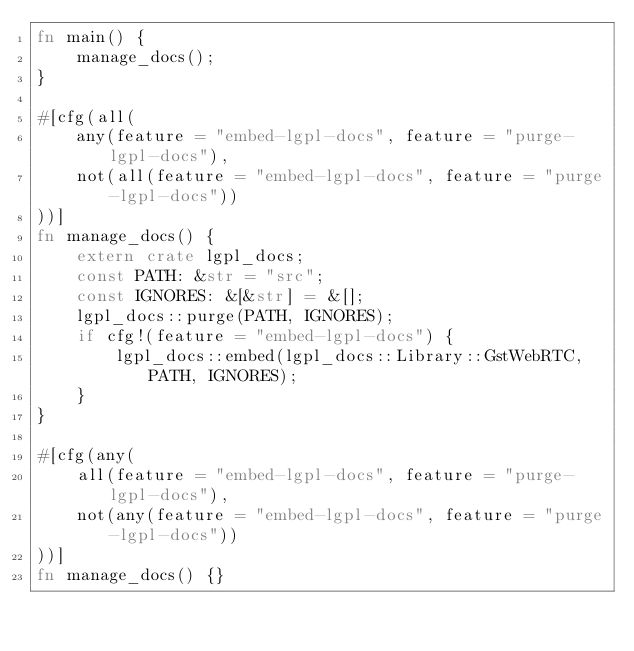<code> <loc_0><loc_0><loc_500><loc_500><_Rust_>fn main() {
    manage_docs();
}

#[cfg(all(
    any(feature = "embed-lgpl-docs", feature = "purge-lgpl-docs"),
    not(all(feature = "embed-lgpl-docs", feature = "purge-lgpl-docs"))
))]
fn manage_docs() {
    extern crate lgpl_docs;
    const PATH: &str = "src";
    const IGNORES: &[&str] = &[];
    lgpl_docs::purge(PATH, IGNORES);
    if cfg!(feature = "embed-lgpl-docs") {
        lgpl_docs::embed(lgpl_docs::Library::GstWebRTC, PATH, IGNORES);
    }
}

#[cfg(any(
    all(feature = "embed-lgpl-docs", feature = "purge-lgpl-docs"),
    not(any(feature = "embed-lgpl-docs", feature = "purge-lgpl-docs"))
))]
fn manage_docs() {}
</code> 